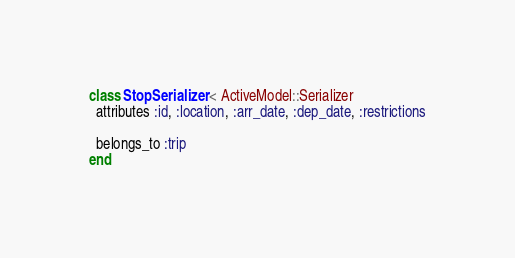Convert code to text. <code><loc_0><loc_0><loc_500><loc_500><_Ruby_>class StopSerializer < ActiveModel::Serializer
  attributes :id, :location, :arr_date, :dep_date, :restrictions

  belongs_to :trip
end
</code> 